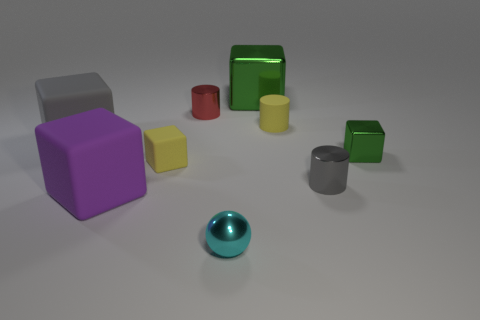What could be the purpose of these objects? These objects may serve educational purposes, for sorting and shape recognition activities, commonly used in teaching environments with children to develop fine motor skills and color and shape identification. How many objects are there in total? There are nine objects in total, consisting of different shapes and colors, varying from cubes, cylinders to a sphere. 